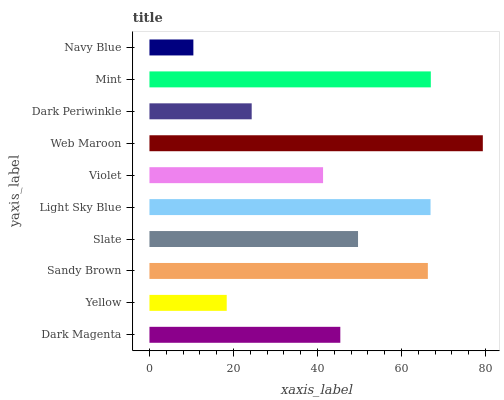Is Navy Blue the minimum?
Answer yes or no. Yes. Is Web Maroon the maximum?
Answer yes or no. Yes. Is Yellow the minimum?
Answer yes or no. No. Is Yellow the maximum?
Answer yes or no. No. Is Dark Magenta greater than Yellow?
Answer yes or no. Yes. Is Yellow less than Dark Magenta?
Answer yes or no. Yes. Is Yellow greater than Dark Magenta?
Answer yes or no. No. Is Dark Magenta less than Yellow?
Answer yes or no. No. Is Slate the high median?
Answer yes or no. Yes. Is Dark Magenta the low median?
Answer yes or no. Yes. Is Yellow the high median?
Answer yes or no. No. Is Navy Blue the low median?
Answer yes or no. No. 